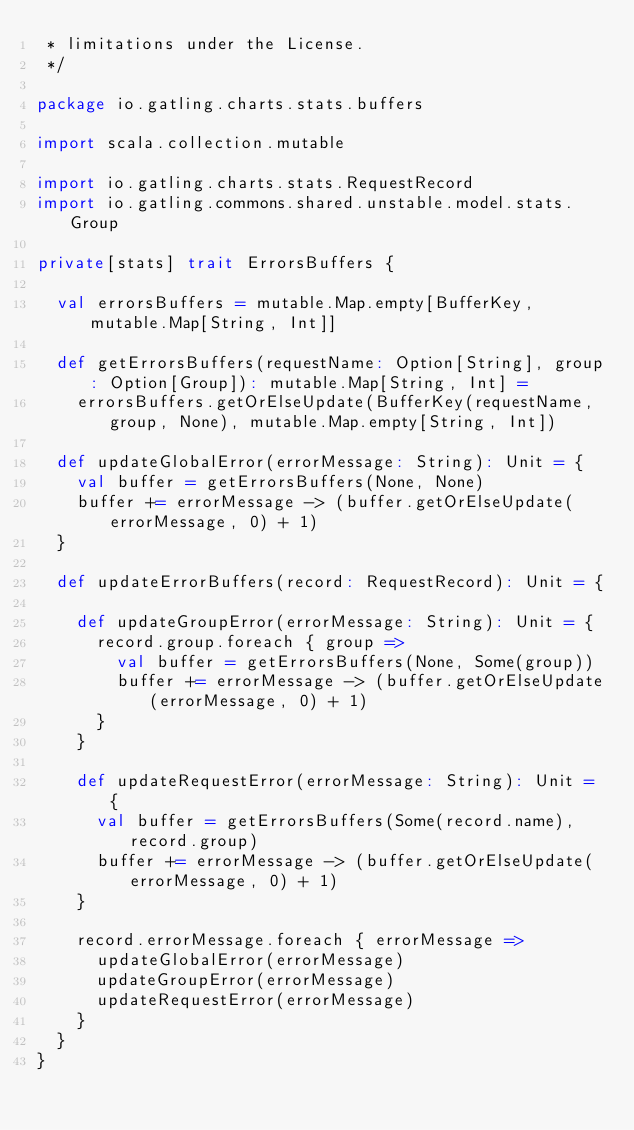<code> <loc_0><loc_0><loc_500><loc_500><_Scala_> * limitations under the License.
 */

package io.gatling.charts.stats.buffers

import scala.collection.mutable

import io.gatling.charts.stats.RequestRecord
import io.gatling.commons.shared.unstable.model.stats.Group

private[stats] trait ErrorsBuffers {

  val errorsBuffers = mutable.Map.empty[BufferKey, mutable.Map[String, Int]]

  def getErrorsBuffers(requestName: Option[String], group: Option[Group]): mutable.Map[String, Int] =
    errorsBuffers.getOrElseUpdate(BufferKey(requestName, group, None), mutable.Map.empty[String, Int])

  def updateGlobalError(errorMessage: String): Unit = {
    val buffer = getErrorsBuffers(None, None)
    buffer += errorMessage -> (buffer.getOrElseUpdate(errorMessage, 0) + 1)
  }

  def updateErrorBuffers(record: RequestRecord): Unit = {

    def updateGroupError(errorMessage: String): Unit = {
      record.group.foreach { group =>
        val buffer = getErrorsBuffers(None, Some(group))
        buffer += errorMessage -> (buffer.getOrElseUpdate(errorMessage, 0) + 1)
      }
    }

    def updateRequestError(errorMessage: String): Unit = {
      val buffer = getErrorsBuffers(Some(record.name), record.group)
      buffer += errorMessage -> (buffer.getOrElseUpdate(errorMessage, 0) + 1)
    }

    record.errorMessage.foreach { errorMessage =>
      updateGlobalError(errorMessage)
      updateGroupError(errorMessage)
      updateRequestError(errorMessage)
    }
  }
}
</code> 